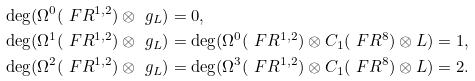Convert formula to latex. <formula><loc_0><loc_0><loc_500><loc_500>& \deg ( \Omega ^ { 0 } ( \ F R ^ { 1 , 2 } ) \otimes \ g _ { L } ) = 0 , \\ & \deg ( \Omega ^ { 1 } ( \ F R ^ { 1 , 2 } ) \otimes \ g _ { L } ) = \deg ( \Omega ^ { 0 } ( \ F R ^ { 1 , 2 } ) \otimes C _ { 1 } ( \ F R ^ { 8 } ) \otimes L ) = 1 , \\ & \deg ( \Omega ^ { 2 } ( \ F R ^ { 1 , 2 } ) \otimes \ g _ { L } ) = \deg ( \Omega ^ { 3 } ( \ F R ^ { 1 , 2 } ) \otimes C _ { 1 } ( \ F R ^ { 8 } ) \otimes L ) = 2 .</formula> 